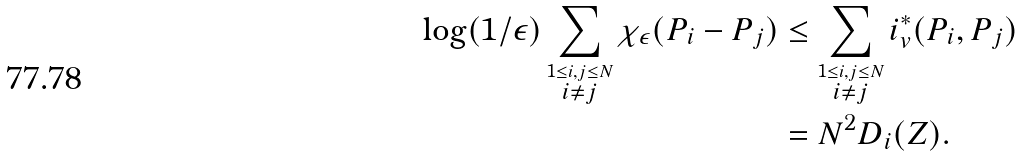Convert formula to latex. <formula><loc_0><loc_0><loc_500><loc_500>\log ( 1 / \epsilon ) \sum _ { \stackrel { 1 \leq i , j \leq N } { i \neq j } } \chi _ { \epsilon } ( P _ { i } - P _ { j } ) & \leq \sum _ { \stackrel { 1 \leq i , j \leq N } { i \neq j } } i _ { v } ^ { * } ( P _ { i } , P _ { j } ) \\ & = N ^ { 2 } D _ { i } ( Z ) .</formula> 